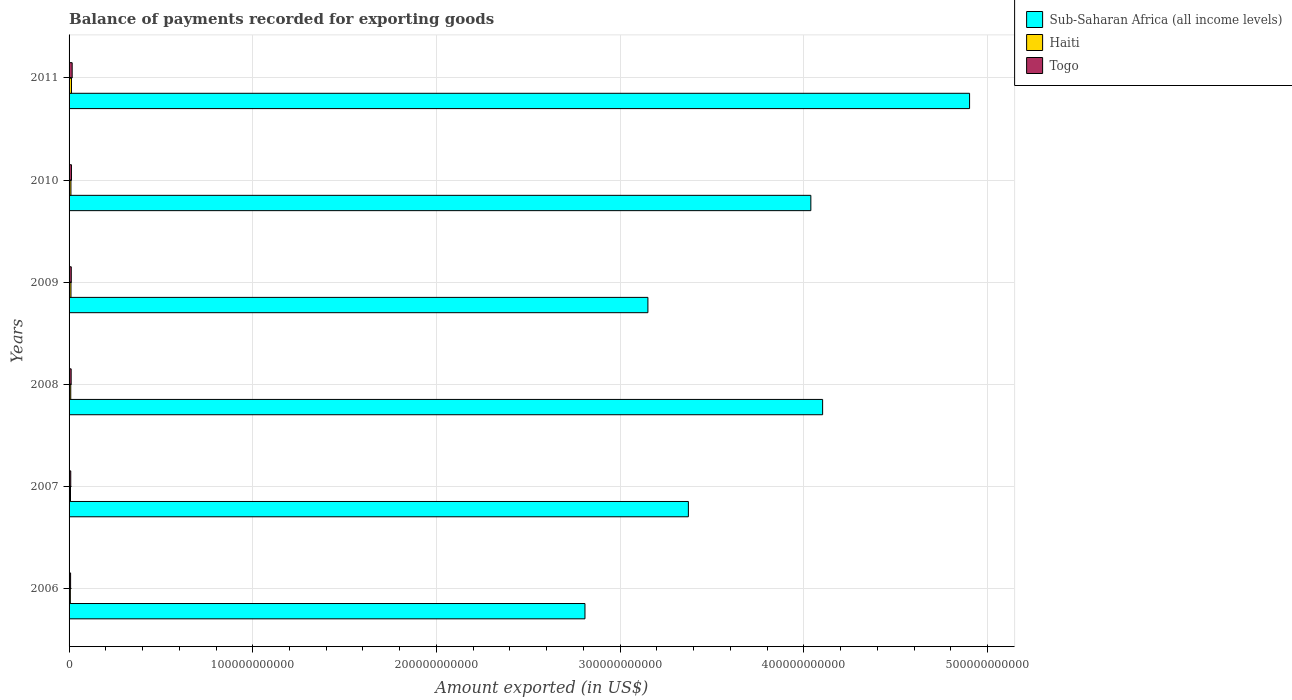How many groups of bars are there?
Provide a short and direct response. 6. Are the number of bars per tick equal to the number of legend labels?
Keep it short and to the point. Yes. How many bars are there on the 2nd tick from the bottom?
Your answer should be very brief. 3. What is the label of the 5th group of bars from the top?
Your answer should be compact. 2007. What is the amount exported in Togo in 2011?
Your response must be concise. 1.69e+09. Across all years, what is the maximum amount exported in Haiti?
Your answer should be very brief. 1.31e+09. Across all years, what is the minimum amount exported in Haiti?
Your response must be concise. 6.89e+08. In which year was the amount exported in Sub-Saharan Africa (all income levels) maximum?
Your response must be concise. 2011. What is the total amount exported in Togo in the graph?
Provide a short and direct response. 7.06e+09. What is the difference between the amount exported in Haiti in 2006 and that in 2007?
Make the answer very short. -9.01e+07. What is the difference between the amount exported in Sub-Saharan Africa (all income levels) in 2006 and the amount exported in Haiti in 2009?
Offer a terse response. 2.80e+11. What is the average amount exported in Togo per year?
Give a very brief answer. 1.18e+09. In the year 2006, what is the difference between the amount exported in Togo and amount exported in Haiti?
Offer a terse response. 1.42e+08. In how many years, is the amount exported in Haiti greater than 320000000000 US$?
Make the answer very short. 0. What is the ratio of the amount exported in Sub-Saharan Africa (all income levels) in 2006 to that in 2009?
Your answer should be compact. 0.89. Is the difference between the amount exported in Togo in 2009 and 2011 greater than the difference between the amount exported in Haiti in 2009 and 2011?
Offer a very short reply. No. What is the difference between the highest and the second highest amount exported in Haiti?
Your answer should be compact. 2.78e+08. What is the difference between the highest and the lowest amount exported in Haiti?
Make the answer very short. 6.23e+08. In how many years, is the amount exported in Sub-Saharan Africa (all income levels) greater than the average amount exported in Sub-Saharan Africa (all income levels) taken over all years?
Keep it short and to the point. 3. What does the 1st bar from the top in 2009 represents?
Your answer should be very brief. Togo. What does the 2nd bar from the bottom in 2008 represents?
Ensure brevity in your answer.  Haiti. What is the difference between two consecutive major ticks on the X-axis?
Make the answer very short. 1.00e+11. How many legend labels are there?
Your answer should be very brief. 3. What is the title of the graph?
Your response must be concise. Balance of payments recorded for exporting goods. Does "India" appear as one of the legend labels in the graph?
Your response must be concise. No. What is the label or title of the X-axis?
Provide a short and direct response. Amount exported (in US$). What is the label or title of the Y-axis?
Keep it short and to the point. Years. What is the Amount exported (in US$) of Sub-Saharan Africa (all income levels) in 2006?
Give a very brief answer. 2.81e+11. What is the Amount exported (in US$) in Haiti in 2006?
Ensure brevity in your answer.  6.89e+08. What is the Amount exported (in US$) of Togo in 2006?
Make the answer very short. 8.31e+08. What is the Amount exported (in US$) in Sub-Saharan Africa (all income levels) in 2007?
Ensure brevity in your answer.  3.37e+11. What is the Amount exported (in US$) of Haiti in 2007?
Offer a terse response. 7.79e+08. What is the Amount exported (in US$) in Togo in 2007?
Make the answer very short. 9.13e+08. What is the Amount exported (in US$) of Sub-Saharan Africa (all income levels) in 2008?
Provide a succinct answer. 4.10e+11. What is the Amount exported (in US$) in Haiti in 2008?
Your answer should be very brief. 9.17e+08. What is the Amount exported (in US$) of Togo in 2008?
Your response must be concise. 1.14e+09. What is the Amount exported (in US$) in Sub-Saharan Africa (all income levels) in 2009?
Provide a succinct answer. 3.15e+11. What is the Amount exported (in US$) in Haiti in 2009?
Make the answer very short. 1.03e+09. What is the Amount exported (in US$) of Togo in 2009?
Provide a short and direct response. 1.20e+09. What is the Amount exported (in US$) in Sub-Saharan Africa (all income levels) in 2010?
Give a very brief answer. 4.04e+11. What is the Amount exported (in US$) of Haiti in 2010?
Provide a succinct answer. 1.02e+09. What is the Amount exported (in US$) of Togo in 2010?
Keep it short and to the point. 1.30e+09. What is the Amount exported (in US$) in Sub-Saharan Africa (all income levels) in 2011?
Offer a terse response. 4.90e+11. What is the Amount exported (in US$) in Haiti in 2011?
Provide a short and direct response. 1.31e+09. What is the Amount exported (in US$) in Togo in 2011?
Give a very brief answer. 1.69e+09. Across all years, what is the maximum Amount exported (in US$) of Sub-Saharan Africa (all income levels)?
Keep it short and to the point. 4.90e+11. Across all years, what is the maximum Amount exported (in US$) in Haiti?
Offer a very short reply. 1.31e+09. Across all years, what is the maximum Amount exported (in US$) of Togo?
Offer a terse response. 1.69e+09. Across all years, what is the minimum Amount exported (in US$) in Sub-Saharan Africa (all income levels)?
Offer a terse response. 2.81e+11. Across all years, what is the minimum Amount exported (in US$) in Haiti?
Offer a very short reply. 6.89e+08. Across all years, what is the minimum Amount exported (in US$) of Togo?
Keep it short and to the point. 8.31e+08. What is the total Amount exported (in US$) in Sub-Saharan Africa (all income levels) in the graph?
Your response must be concise. 2.24e+12. What is the total Amount exported (in US$) in Haiti in the graph?
Your answer should be very brief. 5.75e+09. What is the total Amount exported (in US$) in Togo in the graph?
Offer a terse response. 7.06e+09. What is the difference between the Amount exported (in US$) of Sub-Saharan Africa (all income levels) in 2006 and that in 2007?
Offer a very short reply. -5.63e+1. What is the difference between the Amount exported (in US$) in Haiti in 2006 and that in 2007?
Offer a very short reply. -9.01e+07. What is the difference between the Amount exported (in US$) of Togo in 2006 and that in 2007?
Your answer should be compact. -8.18e+07. What is the difference between the Amount exported (in US$) in Sub-Saharan Africa (all income levels) in 2006 and that in 2008?
Give a very brief answer. -1.29e+11. What is the difference between the Amount exported (in US$) of Haiti in 2006 and that in 2008?
Ensure brevity in your answer.  -2.28e+08. What is the difference between the Amount exported (in US$) of Togo in 2006 and that in 2008?
Your answer should be compact. -3.05e+08. What is the difference between the Amount exported (in US$) in Sub-Saharan Africa (all income levels) in 2006 and that in 2009?
Your answer should be compact. -3.43e+1. What is the difference between the Amount exported (in US$) of Haiti in 2006 and that in 2009?
Your answer should be very brief. -3.45e+08. What is the difference between the Amount exported (in US$) in Togo in 2006 and that in 2009?
Your response must be concise. -3.66e+08. What is the difference between the Amount exported (in US$) in Sub-Saharan Africa (all income levels) in 2006 and that in 2010?
Offer a terse response. -1.23e+11. What is the difference between the Amount exported (in US$) in Haiti in 2006 and that in 2010?
Ensure brevity in your answer.  -3.27e+08. What is the difference between the Amount exported (in US$) of Togo in 2006 and that in 2010?
Offer a terse response. -4.65e+08. What is the difference between the Amount exported (in US$) of Sub-Saharan Africa (all income levels) in 2006 and that in 2011?
Keep it short and to the point. -2.09e+11. What is the difference between the Amount exported (in US$) in Haiti in 2006 and that in 2011?
Give a very brief answer. -6.23e+08. What is the difference between the Amount exported (in US$) in Togo in 2006 and that in 2011?
Offer a very short reply. -8.56e+08. What is the difference between the Amount exported (in US$) in Sub-Saharan Africa (all income levels) in 2007 and that in 2008?
Your answer should be very brief. -7.31e+1. What is the difference between the Amount exported (in US$) in Haiti in 2007 and that in 2008?
Your response must be concise. -1.38e+08. What is the difference between the Amount exported (in US$) of Togo in 2007 and that in 2008?
Offer a very short reply. -2.23e+08. What is the difference between the Amount exported (in US$) in Sub-Saharan Africa (all income levels) in 2007 and that in 2009?
Give a very brief answer. 2.20e+1. What is the difference between the Amount exported (in US$) in Haiti in 2007 and that in 2009?
Make the answer very short. -2.55e+08. What is the difference between the Amount exported (in US$) of Togo in 2007 and that in 2009?
Ensure brevity in your answer.  -2.84e+08. What is the difference between the Amount exported (in US$) of Sub-Saharan Africa (all income levels) in 2007 and that in 2010?
Provide a short and direct response. -6.67e+1. What is the difference between the Amount exported (in US$) of Haiti in 2007 and that in 2010?
Offer a terse response. -2.37e+08. What is the difference between the Amount exported (in US$) in Togo in 2007 and that in 2010?
Ensure brevity in your answer.  -3.83e+08. What is the difference between the Amount exported (in US$) of Sub-Saharan Africa (all income levels) in 2007 and that in 2011?
Give a very brief answer. -1.53e+11. What is the difference between the Amount exported (in US$) of Haiti in 2007 and that in 2011?
Offer a terse response. -5.33e+08. What is the difference between the Amount exported (in US$) of Togo in 2007 and that in 2011?
Provide a short and direct response. -7.75e+08. What is the difference between the Amount exported (in US$) of Sub-Saharan Africa (all income levels) in 2008 and that in 2009?
Your answer should be compact. 9.51e+1. What is the difference between the Amount exported (in US$) of Haiti in 2008 and that in 2009?
Give a very brief answer. -1.17e+08. What is the difference between the Amount exported (in US$) in Togo in 2008 and that in 2009?
Give a very brief answer. -6.09e+07. What is the difference between the Amount exported (in US$) in Sub-Saharan Africa (all income levels) in 2008 and that in 2010?
Your answer should be compact. 6.41e+09. What is the difference between the Amount exported (in US$) in Haiti in 2008 and that in 2010?
Your response must be concise. -9.92e+07. What is the difference between the Amount exported (in US$) in Togo in 2008 and that in 2010?
Ensure brevity in your answer.  -1.61e+08. What is the difference between the Amount exported (in US$) of Sub-Saharan Africa (all income levels) in 2008 and that in 2011?
Ensure brevity in your answer.  -8.00e+1. What is the difference between the Amount exported (in US$) of Haiti in 2008 and that in 2011?
Keep it short and to the point. -3.94e+08. What is the difference between the Amount exported (in US$) of Togo in 2008 and that in 2011?
Offer a terse response. -5.52e+08. What is the difference between the Amount exported (in US$) of Sub-Saharan Africa (all income levels) in 2009 and that in 2010?
Keep it short and to the point. -8.87e+1. What is the difference between the Amount exported (in US$) of Haiti in 2009 and that in 2010?
Provide a short and direct response. 1.76e+07. What is the difference between the Amount exported (in US$) in Togo in 2009 and that in 2010?
Your answer should be very brief. -9.98e+07. What is the difference between the Amount exported (in US$) in Sub-Saharan Africa (all income levels) in 2009 and that in 2011?
Provide a succinct answer. -1.75e+11. What is the difference between the Amount exported (in US$) of Haiti in 2009 and that in 2011?
Keep it short and to the point. -2.78e+08. What is the difference between the Amount exported (in US$) of Togo in 2009 and that in 2011?
Give a very brief answer. -4.91e+08. What is the difference between the Amount exported (in US$) of Sub-Saharan Africa (all income levels) in 2010 and that in 2011?
Offer a very short reply. -8.64e+1. What is the difference between the Amount exported (in US$) of Haiti in 2010 and that in 2011?
Your answer should be very brief. -2.95e+08. What is the difference between the Amount exported (in US$) in Togo in 2010 and that in 2011?
Make the answer very short. -3.91e+08. What is the difference between the Amount exported (in US$) in Sub-Saharan Africa (all income levels) in 2006 and the Amount exported (in US$) in Haiti in 2007?
Your answer should be compact. 2.80e+11. What is the difference between the Amount exported (in US$) in Sub-Saharan Africa (all income levels) in 2006 and the Amount exported (in US$) in Togo in 2007?
Provide a succinct answer. 2.80e+11. What is the difference between the Amount exported (in US$) in Haiti in 2006 and the Amount exported (in US$) in Togo in 2007?
Your response must be concise. -2.24e+08. What is the difference between the Amount exported (in US$) of Sub-Saharan Africa (all income levels) in 2006 and the Amount exported (in US$) of Haiti in 2008?
Make the answer very short. 2.80e+11. What is the difference between the Amount exported (in US$) in Sub-Saharan Africa (all income levels) in 2006 and the Amount exported (in US$) in Togo in 2008?
Your response must be concise. 2.80e+11. What is the difference between the Amount exported (in US$) in Haiti in 2006 and the Amount exported (in US$) in Togo in 2008?
Offer a terse response. -4.47e+08. What is the difference between the Amount exported (in US$) in Sub-Saharan Africa (all income levels) in 2006 and the Amount exported (in US$) in Haiti in 2009?
Provide a succinct answer. 2.80e+11. What is the difference between the Amount exported (in US$) of Sub-Saharan Africa (all income levels) in 2006 and the Amount exported (in US$) of Togo in 2009?
Provide a succinct answer. 2.80e+11. What is the difference between the Amount exported (in US$) in Haiti in 2006 and the Amount exported (in US$) in Togo in 2009?
Provide a succinct answer. -5.07e+08. What is the difference between the Amount exported (in US$) in Sub-Saharan Africa (all income levels) in 2006 and the Amount exported (in US$) in Haiti in 2010?
Ensure brevity in your answer.  2.80e+11. What is the difference between the Amount exported (in US$) in Sub-Saharan Africa (all income levels) in 2006 and the Amount exported (in US$) in Togo in 2010?
Offer a terse response. 2.80e+11. What is the difference between the Amount exported (in US$) of Haiti in 2006 and the Amount exported (in US$) of Togo in 2010?
Provide a succinct answer. -6.07e+08. What is the difference between the Amount exported (in US$) in Sub-Saharan Africa (all income levels) in 2006 and the Amount exported (in US$) in Haiti in 2011?
Make the answer very short. 2.80e+11. What is the difference between the Amount exported (in US$) in Sub-Saharan Africa (all income levels) in 2006 and the Amount exported (in US$) in Togo in 2011?
Ensure brevity in your answer.  2.79e+11. What is the difference between the Amount exported (in US$) of Haiti in 2006 and the Amount exported (in US$) of Togo in 2011?
Your answer should be compact. -9.98e+08. What is the difference between the Amount exported (in US$) of Sub-Saharan Africa (all income levels) in 2007 and the Amount exported (in US$) of Haiti in 2008?
Make the answer very short. 3.36e+11. What is the difference between the Amount exported (in US$) in Sub-Saharan Africa (all income levels) in 2007 and the Amount exported (in US$) in Togo in 2008?
Keep it short and to the point. 3.36e+11. What is the difference between the Amount exported (in US$) in Haiti in 2007 and the Amount exported (in US$) in Togo in 2008?
Your answer should be very brief. -3.57e+08. What is the difference between the Amount exported (in US$) in Sub-Saharan Africa (all income levels) in 2007 and the Amount exported (in US$) in Haiti in 2009?
Keep it short and to the point. 3.36e+11. What is the difference between the Amount exported (in US$) of Sub-Saharan Africa (all income levels) in 2007 and the Amount exported (in US$) of Togo in 2009?
Provide a succinct answer. 3.36e+11. What is the difference between the Amount exported (in US$) in Haiti in 2007 and the Amount exported (in US$) in Togo in 2009?
Your answer should be compact. -4.17e+08. What is the difference between the Amount exported (in US$) in Sub-Saharan Africa (all income levels) in 2007 and the Amount exported (in US$) in Haiti in 2010?
Provide a short and direct response. 3.36e+11. What is the difference between the Amount exported (in US$) of Sub-Saharan Africa (all income levels) in 2007 and the Amount exported (in US$) of Togo in 2010?
Keep it short and to the point. 3.36e+11. What is the difference between the Amount exported (in US$) in Haiti in 2007 and the Amount exported (in US$) in Togo in 2010?
Offer a very short reply. -5.17e+08. What is the difference between the Amount exported (in US$) of Sub-Saharan Africa (all income levels) in 2007 and the Amount exported (in US$) of Haiti in 2011?
Ensure brevity in your answer.  3.36e+11. What is the difference between the Amount exported (in US$) of Sub-Saharan Africa (all income levels) in 2007 and the Amount exported (in US$) of Togo in 2011?
Keep it short and to the point. 3.35e+11. What is the difference between the Amount exported (in US$) in Haiti in 2007 and the Amount exported (in US$) in Togo in 2011?
Provide a short and direct response. -9.08e+08. What is the difference between the Amount exported (in US$) in Sub-Saharan Africa (all income levels) in 2008 and the Amount exported (in US$) in Haiti in 2009?
Your answer should be very brief. 4.09e+11. What is the difference between the Amount exported (in US$) of Sub-Saharan Africa (all income levels) in 2008 and the Amount exported (in US$) of Togo in 2009?
Offer a terse response. 4.09e+11. What is the difference between the Amount exported (in US$) in Haiti in 2008 and the Amount exported (in US$) in Togo in 2009?
Your answer should be compact. -2.79e+08. What is the difference between the Amount exported (in US$) in Sub-Saharan Africa (all income levels) in 2008 and the Amount exported (in US$) in Haiti in 2010?
Offer a terse response. 4.09e+11. What is the difference between the Amount exported (in US$) in Sub-Saharan Africa (all income levels) in 2008 and the Amount exported (in US$) in Togo in 2010?
Provide a short and direct response. 4.09e+11. What is the difference between the Amount exported (in US$) of Haiti in 2008 and the Amount exported (in US$) of Togo in 2010?
Provide a short and direct response. -3.79e+08. What is the difference between the Amount exported (in US$) in Sub-Saharan Africa (all income levels) in 2008 and the Amount exported (in US$) in Haiti in 2011?
Give a very brief answer. 4.09e+11. What is the difference between the Amount exported (in US$) of Sub-Saharan Africa (all income levels) in 2008 and the Amount exported (in US$) of Togo in 2011?
Offer a very short reply. 4.09e+11. What is the difference between the Amount exported (in US$) of Haiti in 2008 and the Amount exported (in US$) of Togo in 2011?
Make the answer very short. -7.70e+08. What is the difference between the Amount exported (in US$) of Sub-Saharan Africa (all income levels) in 2009 and the Amount exported (in US$) of Haiti in 2010?
Offer a very short reply. 3.14e+11. What is the difference between the Amount exported (in US$) in Sub-Saharan Africa (all income levels) in 2009 and the Amount exported (in US$) in Togo in 2010?
Offer a terse response. 3.14e+11. What is the difference between the Amount exported (in US$) of Haiti in 2009 and the Amount exported (in US$) of Togo in 2010?
Offer a terse response. -2.62e+08. What is the difference between the Amount exported (in US$) of Sub-Saharan Africa (all income levels) in 2009 and the Amount exported (in US$) of Haiti in 2011?
Your answer should be compact. 3.14e+11. What is the difference between the Amount exported (in US$) in Sub-Saharan Africa (all income levels) in 2009 and the Amount exported (in US$) in Togo in 2011?
Make the answer very short. 3.13e+11. What is the difference between the Amount exported (in US$) in Haiti in 2009 and the Amount exported (in US$) in Togo in 2011?
Your answer should be compact. -6.54e+08. What is the difference between the Amount exported (in US$) of Sub-Saharan Africa (all income levels) in 2010 and the Amount exported (in US$) of Haiti in 2011?
Offer a very short reply. 4.03e+11. What is the difference between the Amount exported (in US$) of Sub-Saharan Africa (all income levels) in 2010 and the Amount exported (in US$) of Togo in 2011?
Your response must be concise. 4.02e+11. What is the difference between the Amount exported (in US$) of Haiti in 2010 and the Amount exported (in US$) of Togo in 2011?
Ensure brevity in your answer.  -6.71e+08. What is the average Amount exported (in US$) in Sub-Saharan Africa (all income levels) per year?
Make the answer very short. 3.73e+11. What is the average Amount exported (in US$) of Haiti per year?
Give a very brief answer. 9.58e+08. What is the average Amount exported (in US$) of Togo per year?
Provide a short and direct response. 1.18e+09. In the year 2006, what is the difference between the Amount exported (in US$) in Sub-Saharan Africa (all income levels) and Amount exported (in US$) in Haiti?
Your answer should be compact. 2.80e+11. In the year 2006, what is the difference between the Amount exported (in US$) in Sub-Saharan Africa (all income levels) and Amount exported (in US$) in Togo?
Make the answer very short. 2.80e+11. In the year 2006, what is the difference between the Amount exported (in US$) in Haiti and Amount exported (in US$) in Togo?
Offer a very short reply. -1.42e+08. In the year 2007, what is the difference between the Amount exported (in US$) of Sub-Saharan Africa (all income levels) and Amount exported (in US$) of Haiti?
Provide a succinct answer. 3.36e+11. In the year 2007, what is the difference between the Amount exported (in US$) in Sub-Saharan Africa (all income levels) and Amount exported (in US$) in Togo?
Provide a short and direct response. 3.36e+11. In the year 2007, what is the difference between the Amount exported (in US$) of Haiti and Amount exported (in US$) of Togo?
Provide a succinct answer. -1.34e+08. In the year 2008, what is the difference between the Amount exported (in US$) of Sub-Saharan Africa (all income levels) and Amount exported (in US$) of Haiti?
Your answer should be compact. 4.09e+11. In the year 2008, what is the difference between the Amount exported (in US$) of Sub-Saharan Africa (all income levels) and Amount exported (in US$) of Togo?
Keep it short and to the point. 4.09e+11. In the year 2008, what is the difference between the Amount exported (in US$) in Haiti and Amount exported (in US$) in Togo?
Keep it short and to the point. -2.18e+08. In the year 2009, what is the difference between the Amount exported (in US$) in Sub-Saharan Africa (all income levels) and Amount exported (in US$) in Haiti?
Offer a very short reply. 3.14e+11. In the year 2009, what is the difference between the Amount exported (in US$) of Sub-Saharan Africa (all income levels) and Amount exported (in US$) of Togo?
Keep it short and to the point. 3.14e+11. In the year 2009, what is the difference between the Amount exported (in US$) in Haiti and Amount exported (in US$) in Togo?
Your answer should be compact. -1.63e+08. In the year 2010, what is the difference between the Amount exported (in US$) of Sub-Saharan Africa (all income levels) and Amount exported (in US$) of Haiti?
Your answer should be compact. 4.03e+11. In the year 2010, what is the difference between the Amount exported (in US$) in Sub-Saharan Africa (all income levels) and Amount exported (in US$) in Togo?
Your answer should be compact. 4.03e+11. In the year 2010, what is the difference between the Amount exported (in US$) of Haiti and Amount exported (in US$) of Togo?
Offer a terse response. -2.80e+08. In the year 2011, what is the difference between the Amount exported (in US$) of Sub-Saharan Africa (all income levels) and Amount exported (in US$) of Haiti?
Keep it short and to the point. 4.89e+11. In the year 2011, what is the difference between the Amount exported (in US$) of Sub-Saharan Africa (all income levels) and Amount exported (in US$) of Togo?
Give a very brief answer. 4.89e+11. In the year 2011, what is the difference between the Amount exported (in US$) in Haiti and Amount exported (in US$) in Togo?
Provide a succinct answer. -3.76e+08. What is the ratio of the Amount exported (in US$) in Sub-Saharan Africa (all income levels) in 2006 to that in 2007?
Give a very brief answer. 0.83. What is the ratio of the Amount exported (in US$) of Haiti in 2006 to that in 2007?
Provide a short and direct response. 0.88. What is the ratio of the Amount exported (in US$) of Togo in 2006 to that in 2007?
Give a very brief answer. 0.91. What is the ratio of the Amount exported (in US$) in Sub-Saharan Africa (all income levels) in 2006 to that in 2008?
Provide a short and direct response. 0.68. What is the ratio of the Amount exported (in US$) in Haiti in 2006 to that in 2008?
Provide a short and direct response. 0.75. What is the ratio of the Amount exported (in US$) in Togo in 2006 to that in 2008?
Your answer should be compact. 0.73. What is the ratio of the Amount exported (in US$) of Sub-Saharan Africa (all income levels) in 2006 to that in 2009?
Your answer should be compact. 0.89. What is the ratio of the Amount exported (in US$) of Haiti in 2006 to that in 2009?
Offer a very short reply. 0.67. What is the ratio of the Amount exported (in US$) in Togo in 2006 to that in 2009?
Offer a very short reply. 0.69. What is the ratio of the Amount exported (in US$) in Sub-Saharan Africa (all income levels) in 2006 to that in 2010?
Your response must be concise. 0.7. What is the ratio of the Amount exported (in US$) in Haiti in 2006 to that in 2010?
Ensure brevity in your answer.  0.68. What is the ratio of the Amount exported (in US$) of Togo in 2006 to that in 2010?
Your answer should be very brief. 0.64. What is the ratio of the Amount exported (in US$) of Sub-Saharan Africa (all income levels) in 2006 to that in 2011?
Make the answer very short. 0.57. What is the ratio of the Amount exported (in US$) of Haiti in 2006 to that in 2011?
Your response must be concise. 0.53. What is the ratio of the Amount exported (in US$) in Togo in 2006 to that in 2011?
Provide a short and direct response. 0.49. What is the ratio of the Amount exported (in US$) of Sub-Saharan Africa (all income levels) in 2007 to that in 2008?
Keep it short and to the point. 0.82. What is the ratio of the Amount exported (in US$) of Haiti in 2007 to that in 2008?
Provide a succinct answer. 0.85. What is the ratio of the Amount exported (in US$) in Togo in 2007 to that in 2008?
Your response must be concise. 0.8. What is the ratio of the Amount exported (in US$) in Sub-Saharan Africa (all income levels) in 2007 to that in 2009?
Make the answer very short. 1.07. What is the ratio of the Amount exported (in US$) of Haiti in 2007 to that in 2009?
Give a very brief answer. 0.75. What is the ratio of the Amount exported (in US$) in Togo in 2007 to that in 2009?
Offer a very short reply. 0.76. What is the ratio of the Amount exported (in US$) of Sub-Saharan Africa (all income levels) in 2007 to that in 2010?
Keep it short and to the point. 0.83. What is the ratio of the Amount exported (in US$) of Haiti in 2007 to that in 2010?
Your response must be concise. 0.77. What is the ratio of the Amount exported (in US$) of Togo in 2007 to that in 2010?
Your answer should be compact. 0.7. What is the ratio of the Amount exported (in US$) in Sub-Saharan Africa (all income levels) in 2007 to that in 2011?
Provide a short and direct response. 0.69. What is the ratio of the Amount exported (in US$) of Haiti in 2007 to that in 2011?
Your answer should be very brief. 0.59. What is the ratio of the Amount exported (in US$) in Togo in 2007 to that in 2011?
Offer a terse response. 0.54. What is the ratio of the Amount exported (in US$) in Sub-Saharan Africa (all income levels) in 2008 to that in 2009?
Your answer should be very brief. 1.3. What is the ratio of the Amount exported (in US$) of Haiti in 2008 to that in 2009?
Provide a short and direct response. 0.89. What is the ratio of the Amount exported (in US$) in Togo in 2008 to that in 2009?
Provide a short and direct response. 0.95. What is the ratio of the Amount exported (in US$) of Sub-Saharan Africa (all income levels) in 2008 to that in 2010?
Ensure brevity in your answer.  1.02. What is the ratio of the Amount exported (in US$) of Haiti in 2008 to that in 2010?
Your answer should be compact. 0.9. What is the ratio of the Amount exported (in US$) in Togo in 2008 to that in 2010?
Your answer should be very brief. 0.88. What is the ratio of the Amount exported (in US$) of Sub-Saharan Africa (all income levels) in 2008 to that in 2011?
Keep it short and to the point. 0.84. What is the ratio of the Amount exported (in US$) in Haiti in 2008 to that in 2011?
Offer a very short reply. 0.7. What is the ratio of the Amount exported (in US$) in Togo in 2008 to that in 2011?
Provide a succinct answer. 0.67. What is the ratio of the Amount exported (in US$) of Sub-Saharan Africa (all income levels) in 2009 to that in 2010?
Offer a very short reply. 0.78. What is the ratio of the Amount exported (in US$) of Haiti in 2009 to that in 2010?
Your response must be concise. 1.02. What is the ratio of the Amount exported (in US$) of Togo in 2009 to that in 2010?
Your response must be concise. 0.92. What is the ratio of the Amount exported (in US$) in Sub-Saharan Africa (all income levels) in 2009 to that in 2011?
Your response must be concise. 0.64. What is the ratio of the Amount exported (in US$) of Haiti in 2009 to that in 2011?
Make the answer very short. 0.79. What is the ratio of the Amount exported (in US$) of Togo in 2009 to that in 2011?
Offer a terse response. 0.71. What is the ratio of the Amount exported (in US$) of Sub-Saharan Africa (all income levels) in 2010 to that in 2011?
Make the answer very short. 0.82. What is the ratio of the Amount exported (in US$) of Haiti in 2010 to that in 2011?
Ensure brevity in your answer.  0.77. What is the ratio of the Amount exported (in US$) of Togo in 2010 to that in 2011?
Keep it short and to the point. 0.77. What is the difference between the highest and the second highest Amount exported (in US$) of Sub-Saharan Africa (all income levels)?
Offer a very short reply. 8.00e+1. What is the difference between the highest and the second highest Amount exported (in US$) of Haiti?
Provide a short and direct response. 2.78e+08. What is the difference between the highest and the second highest Amount exported (in US$) of Togo?
Keep it short and to the point. 3.91e+08. What is the difference between the highest and the lowest Amount exported (in US$) of Sub-Saharan Africa (all income levels)?
Your response must be concise. 2.09e+11. What is the difference between the highest and the lowest Amount exported (in US$) in Haiti?
Offer a very short reply. 6.23e+08. What is the difference between the highest and the lowest Amount exported (in US$) of Togo?
Keep it short and to the point. 8.56e+08. 